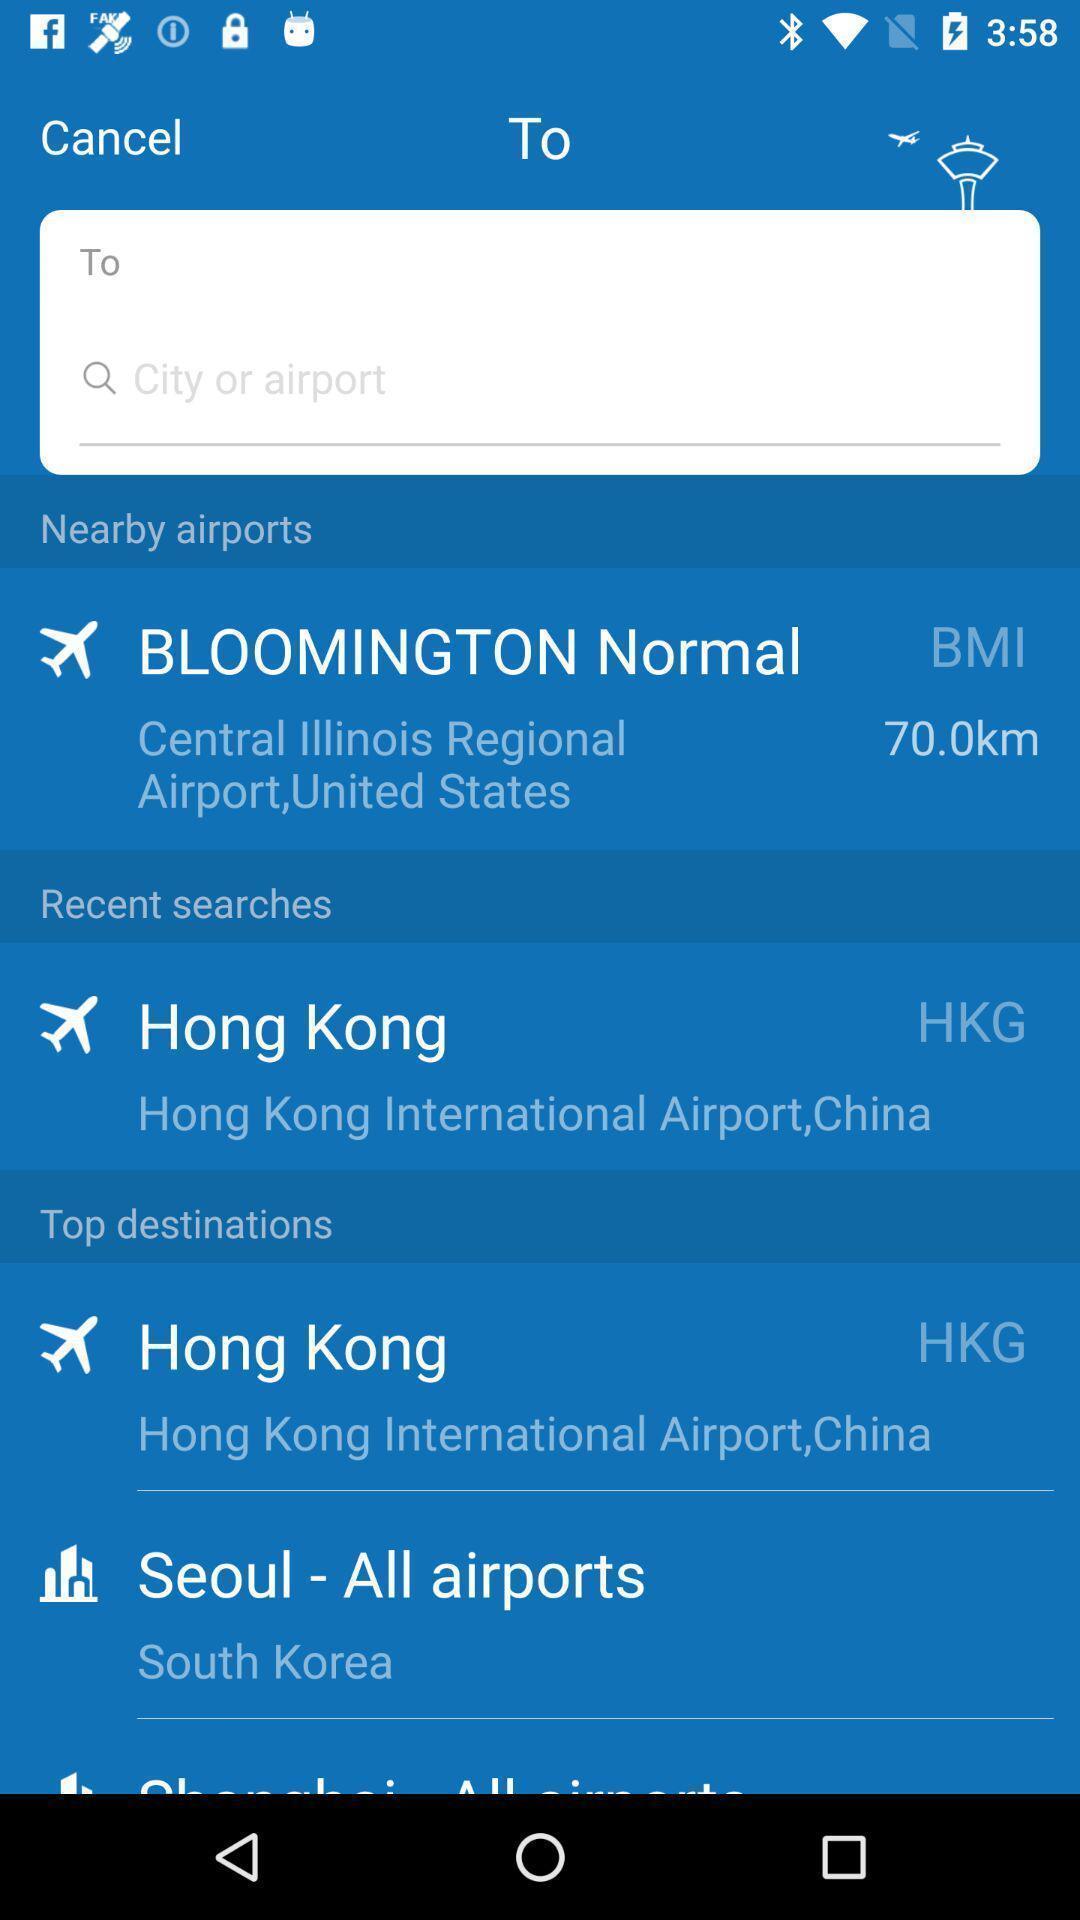Please provide a description for this image. Search bar to find nearby airports. 